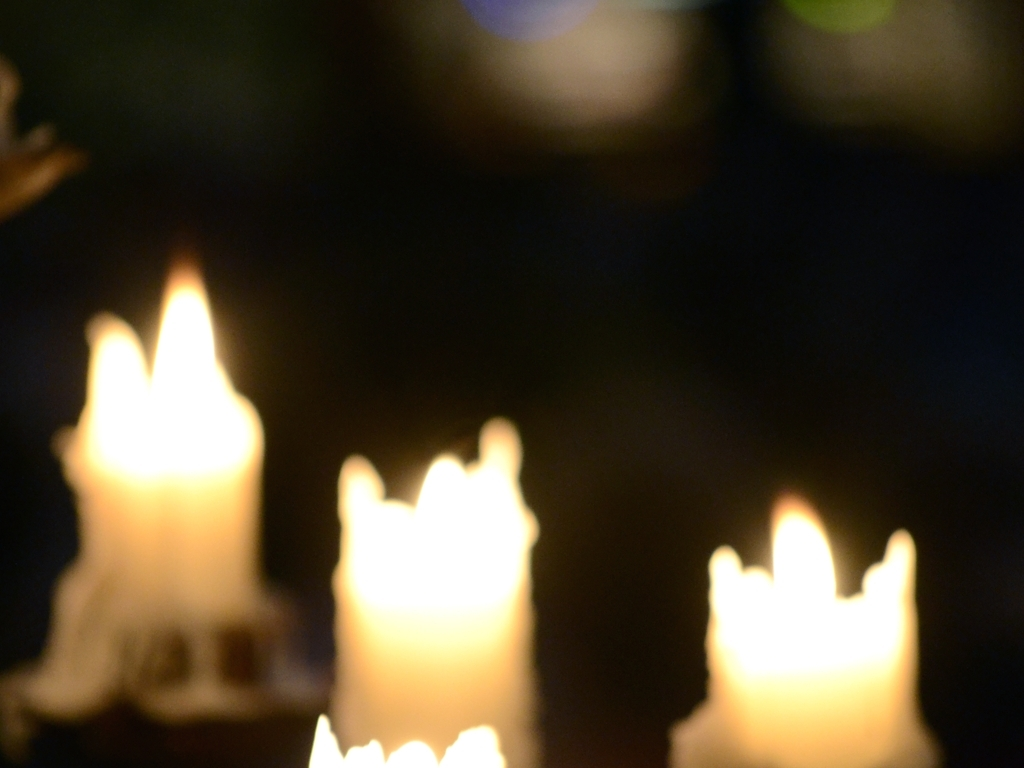How could this image be used effectively in a design or art piece? This image could be used as a background to evoke a soft, dreamy feeling. It could also complement themes of memory, nostalgia, or the passing of time. Furthermore, the warm tones could be used to enhance a cozy ambiance in interior design or artwork. 